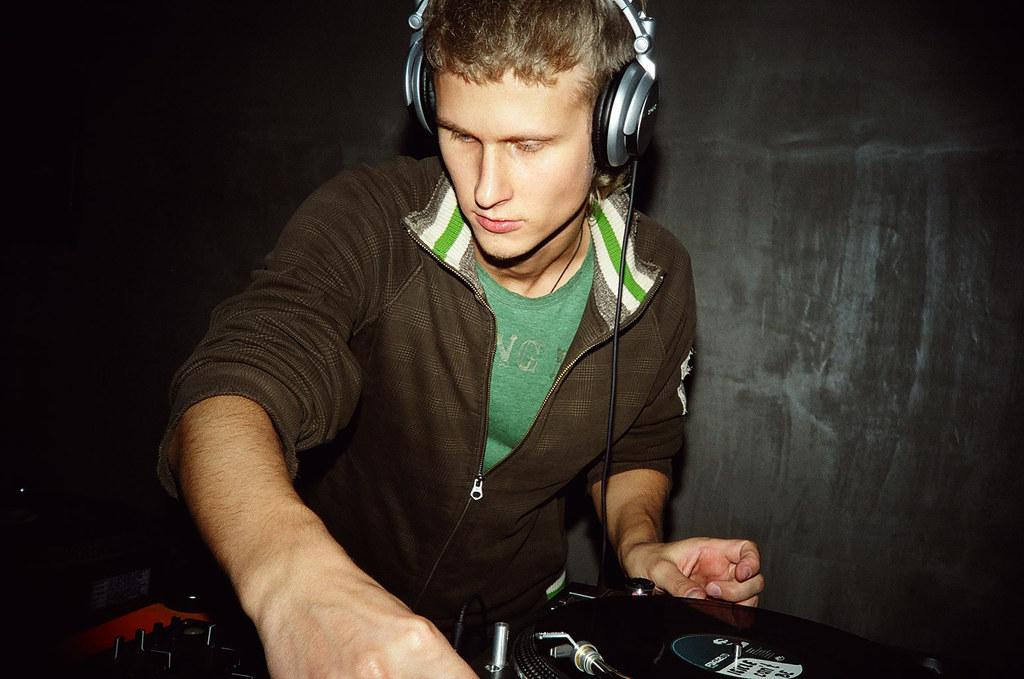What can be seen in the image? There is there a person in the image? What is the person wearing? The person is wearing a headset. What is in front of the person? There are a few objects in front of the person. What is behind the person? There is a wall behind the person. What type of library is visible in the image? There is no library present in the image. What selection of books can be seen on the person's headset? The person is wearing a headset, not a selection of books. 